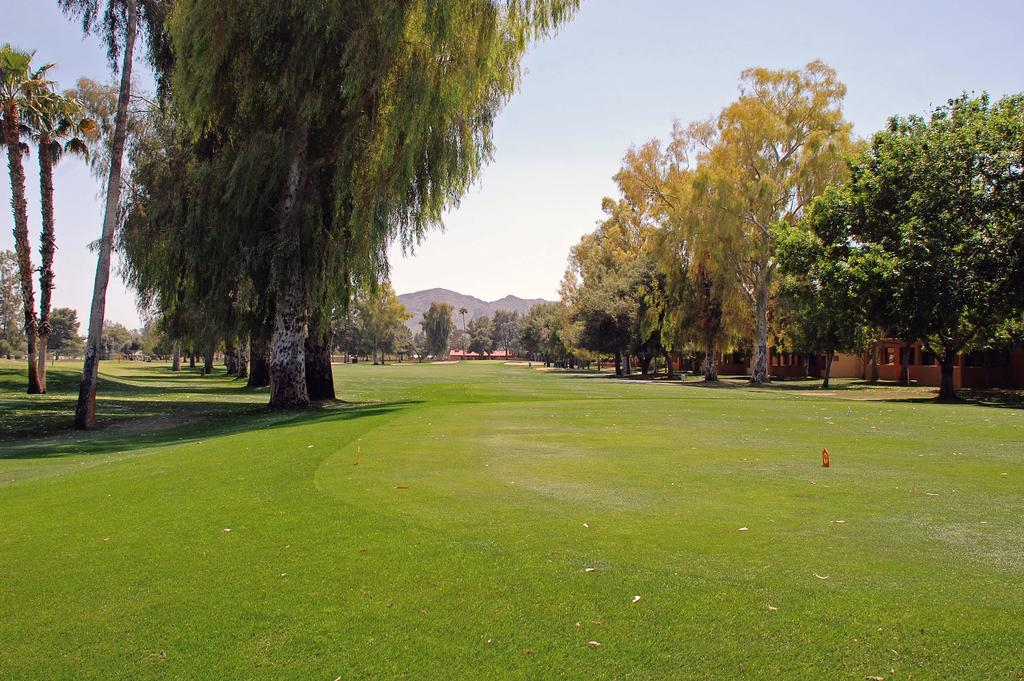What type of vegetation can be seen in the image? There are trees in the image. What type of structures are present in the image? There are houses in the image. What type of ground cover is visible in the image? There is grass in the image. What type of geographical feature can be seen in the image? There are hills in the image. What is visible in the background of the image? The sky is visible in the image. Can you tell me how many guitars are being played on the roof of the houses in the image? There are no guitars or people playing them on the roofs of the houses in the image. What level of comfort can be observed in the image? The image does not provide any information about the level of comfort experienced by anyone or anything in the image. 